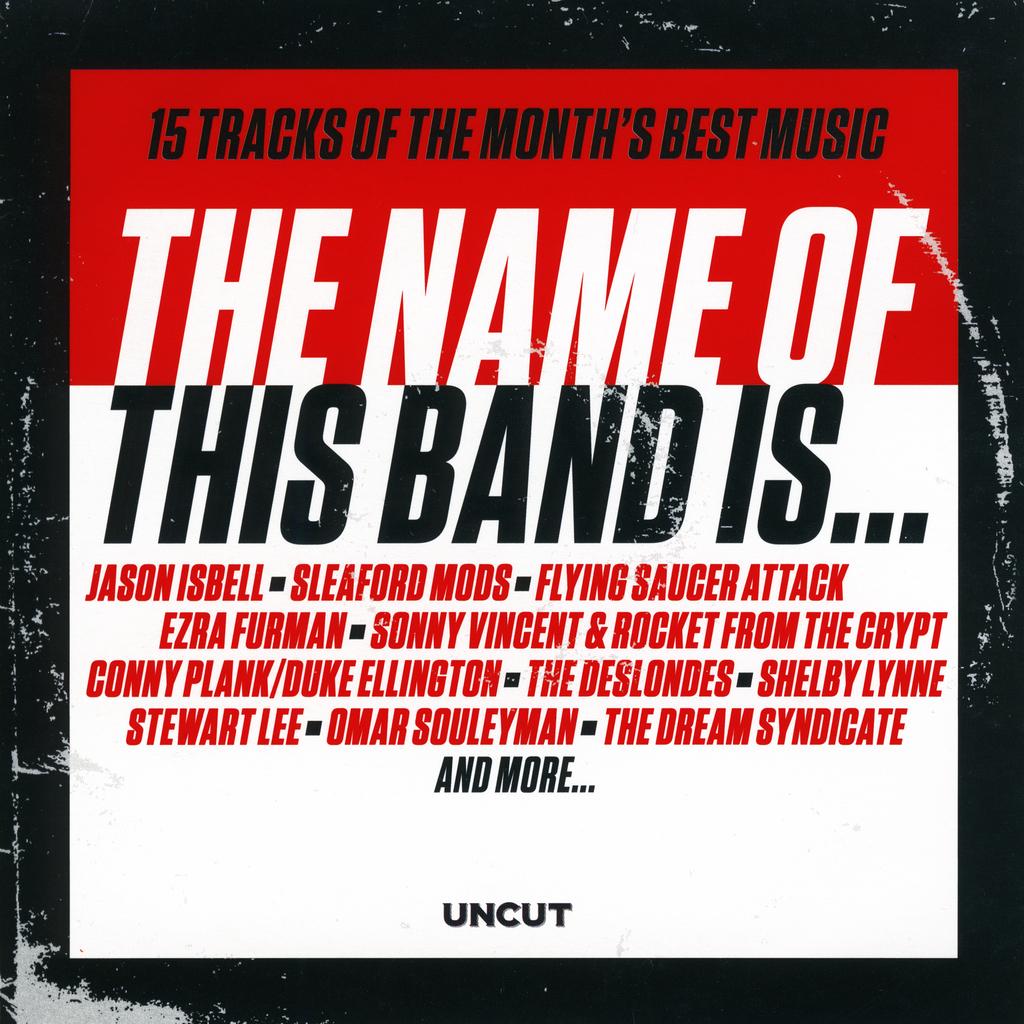How many tracks are on this?
Give a very brief answer. 15. What are the 15 tracks for?
Ensure brevity in your answer.  Month's best music. 